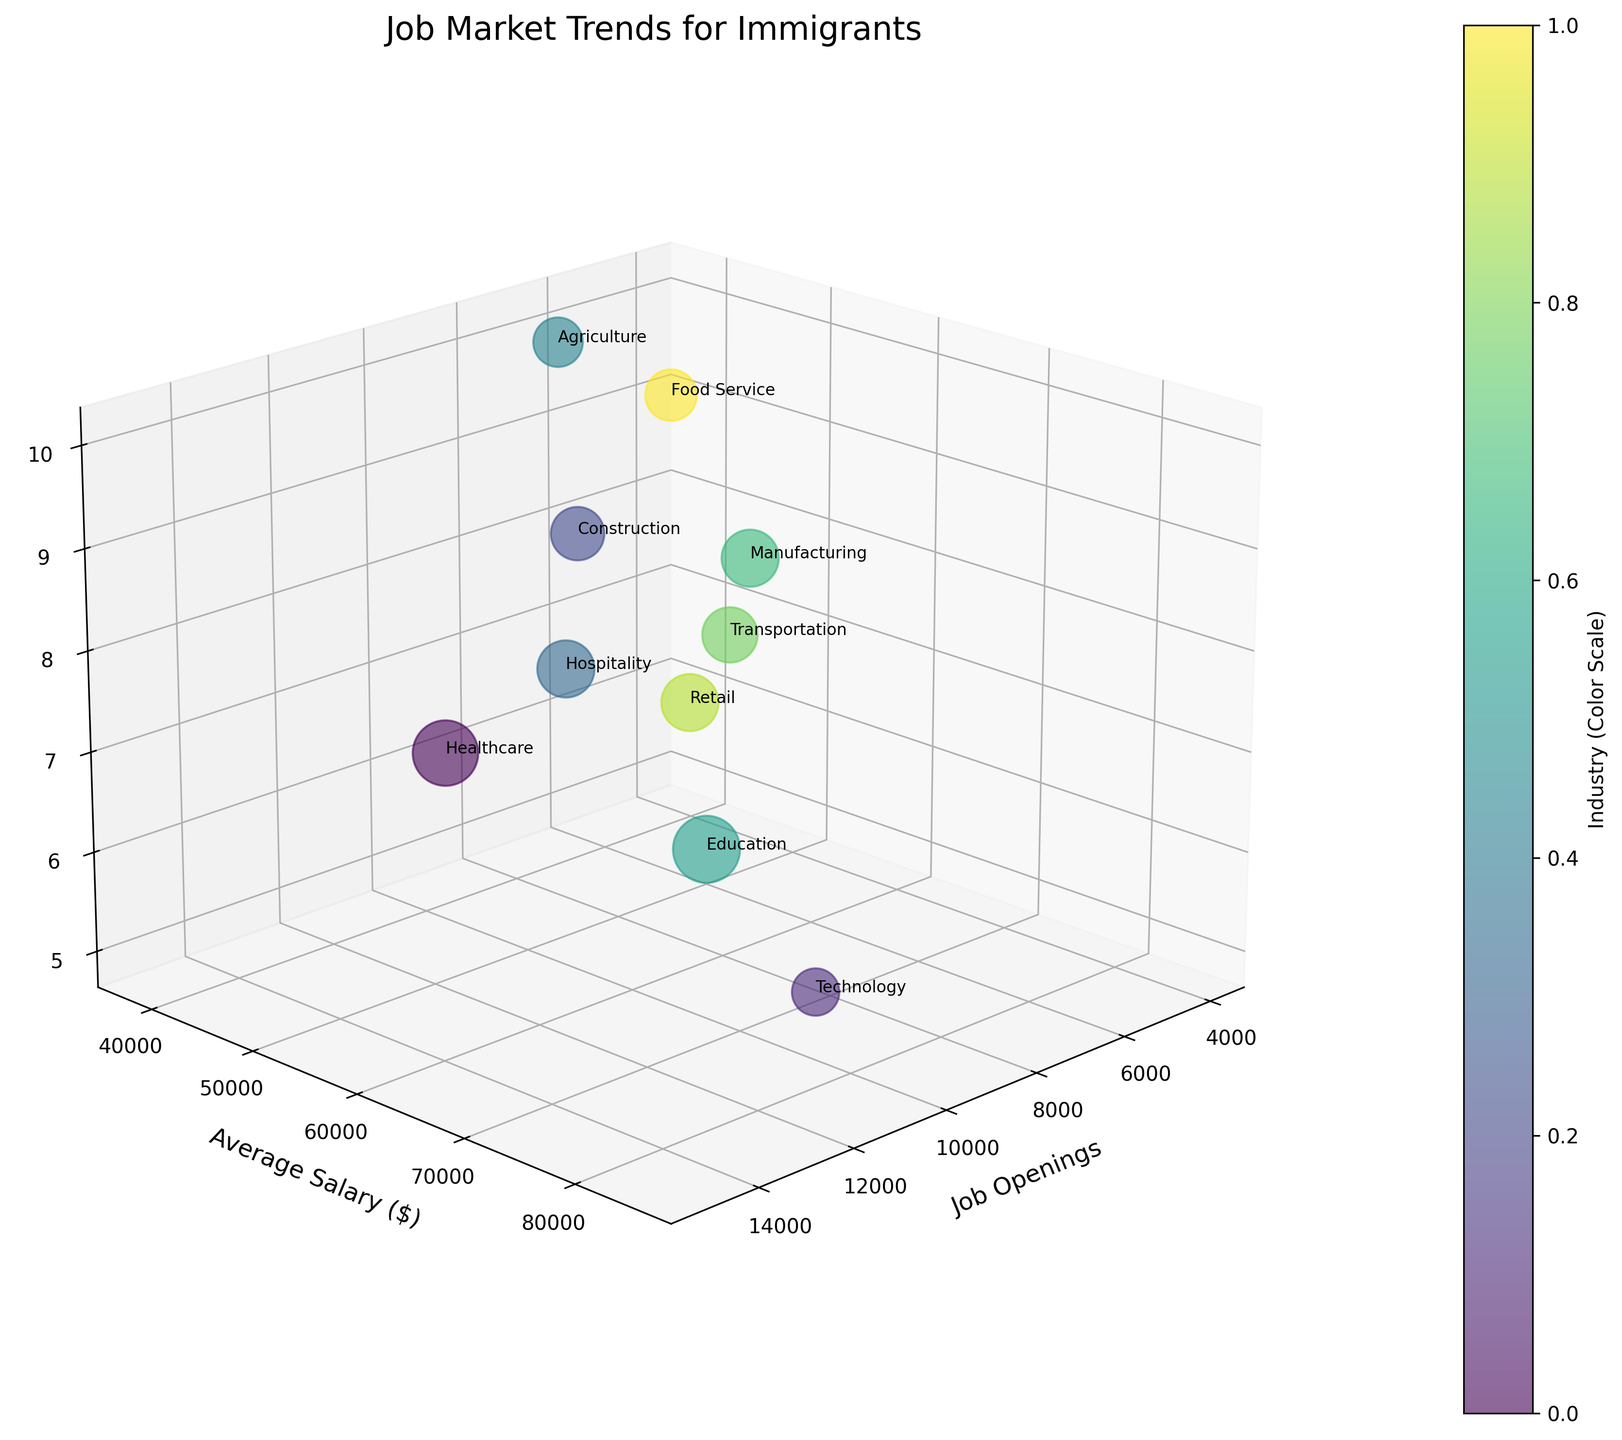What is the title of the figure? The title of the figure is indicated at the top of the plot.
Answer: Job Market Trends for Immigrants What does the x-axis represent? The label of the x-axis specifies what it represents.
Answer: Job Openings Which industry has the highest average salary? By examining the y-axis and the bubble positions, the industry with the highest average salary is identified.
Answer: Technology How many job openings are there in the Technology industry? Find the bubble labeled "Technology" and read the value on the x-axis.
Answer: 12,000 Which two industries have the largest immigrant populations? By checking the z-axis, the two industries with the highest values represent the largest immigrant populations.
Answer: Agriculture and Construction Which industry has the smallest bubble size, and what does it indicate? The smallest bubble represents the shortest length of required skills, which is indicated by the size of the bubble.
Answer: Food Service; it indicates the shortest required skills What is the average salary in the Education industry? Locate the "Education" bubble and determine its position on the y-axis.
Answer: $50,000 Compare and contrast the job openings between the Healthcare and Transportation industries. By examining the x-axis values for the "Healthcare" and "Transportation" bubbles, compare the number of job openings.
Answer: Healthcare: 15,000; Transportation: 5,000 Which industry has the most job openings, and what is the required skill for that industry? Identify the industry with the highest value on the x-axis and check the corresponding required skill.
Answer: Healthcare; Medical Certification What is the total number of job openings across the Construction and Retail industries? Sum the x-axis values for the "Construction" and "Retail" bubbles.
Answer: 10,000 + 4,500 = 14,500 